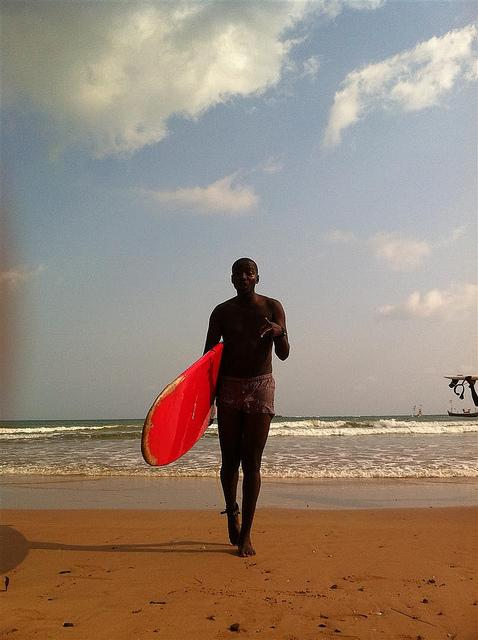What country is this most likely?

Choices:
A) china
B) ireland
C) jamaica
D) russia jamaica 